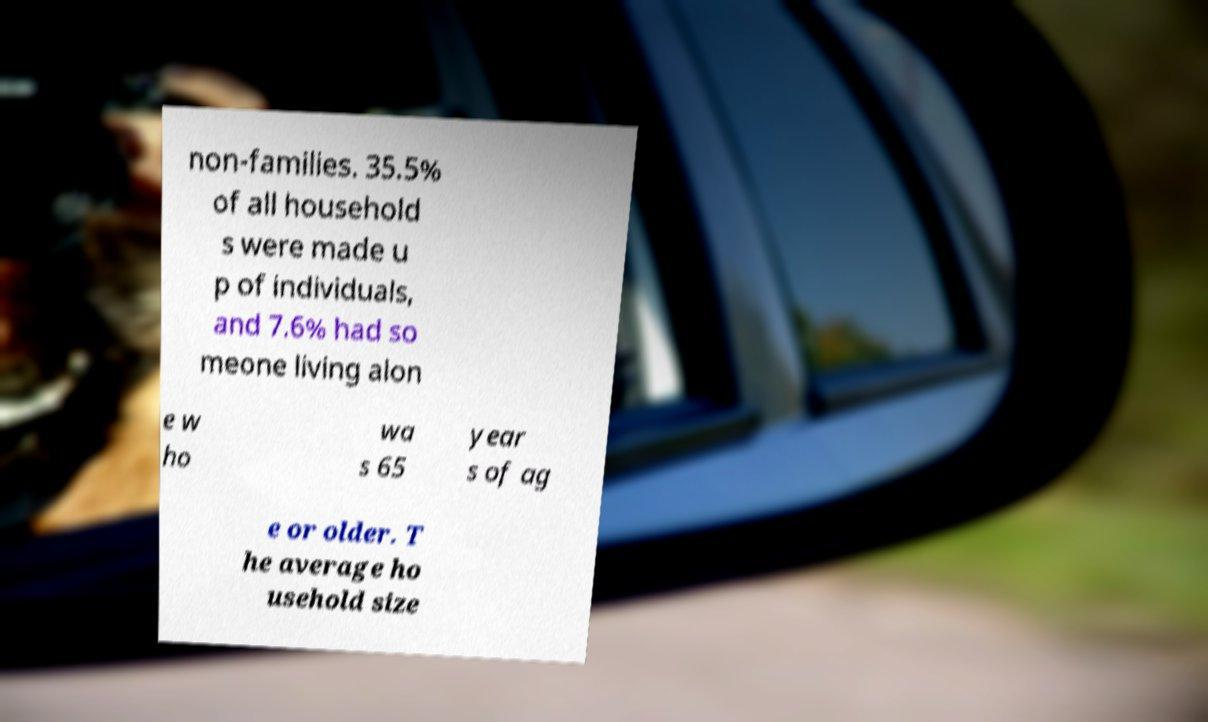Can you read and provide the text displayed in the image?This photo seems to have some interesting text. Can you extract and type it out for me? non-families. 35.5% of all household s were made u p of individuals, and 7.6% had so meone living alon e w ho wa s 65 year s of ag e or older. T he average ho usehold size 